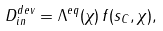Convert formula to latex. <formula><loc_0><loc_0><loc_500><loc_500>D _ { i n } ^ { d e v } = \Lambda ^ { e q } ( \chi ) \, f ( s _ { C } , \chi ) ,</formula> 